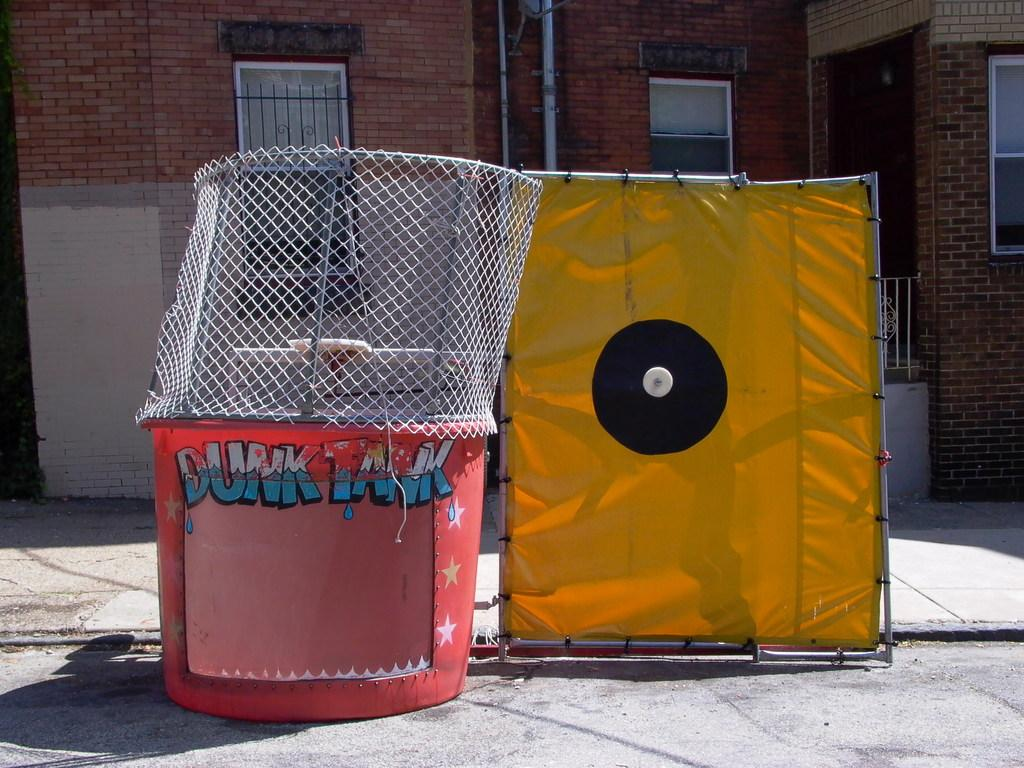<image>
Describe the image concisely. A red "dunk tank" sits next to a yellow cloth outside of a building 